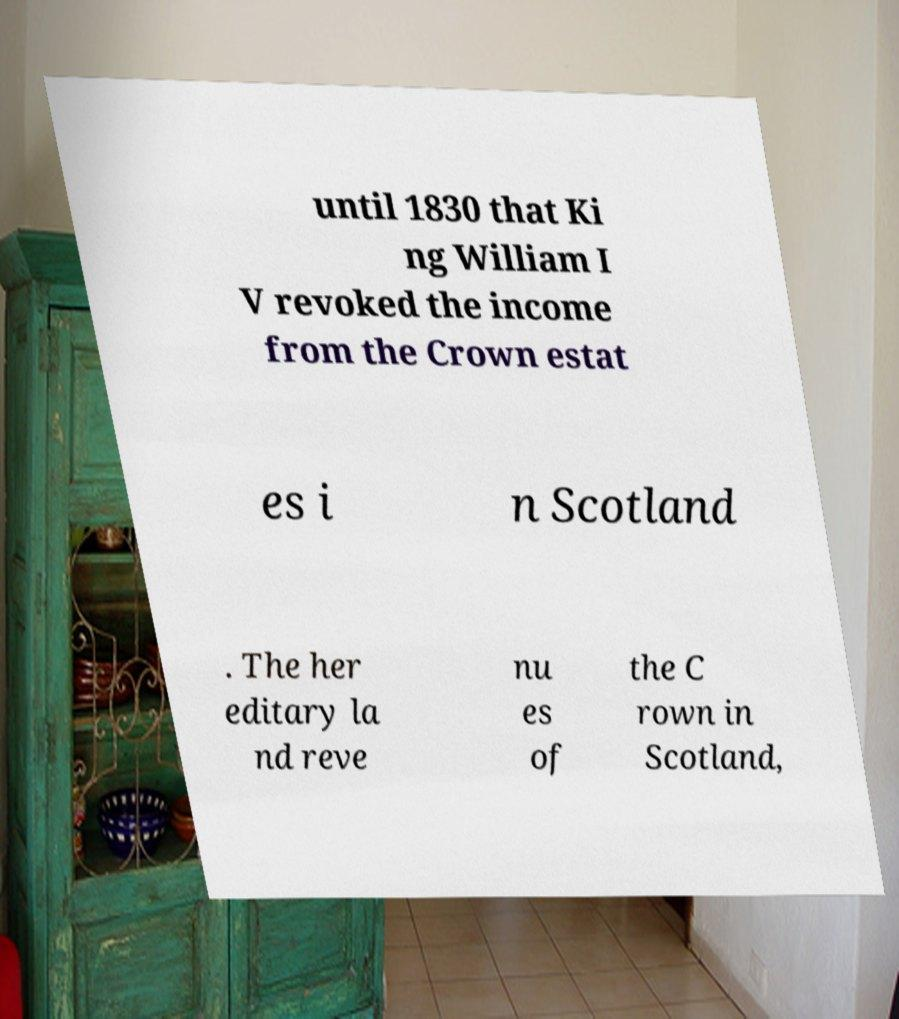There's text embedded in this image that I need extracted. Can you transcribe it verbatim? until 1830 that Ki ng William I V revoked the income from the Crown estat es i n Scotland . The her editary la nd reve nu es of the C rown in Scotland, 